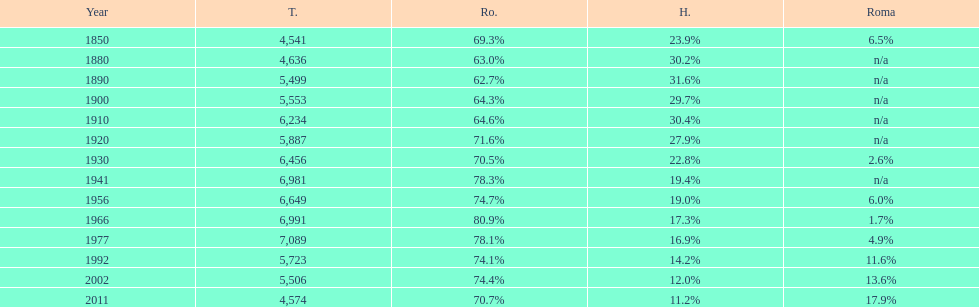How many hungarians were there in the year 1850? 23.9%. 